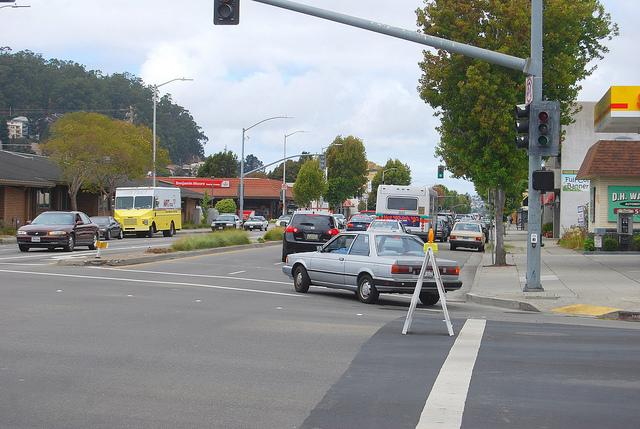What type of traffic does this road have? Please explain your reasoning. heavy. The traffic is heavy. 